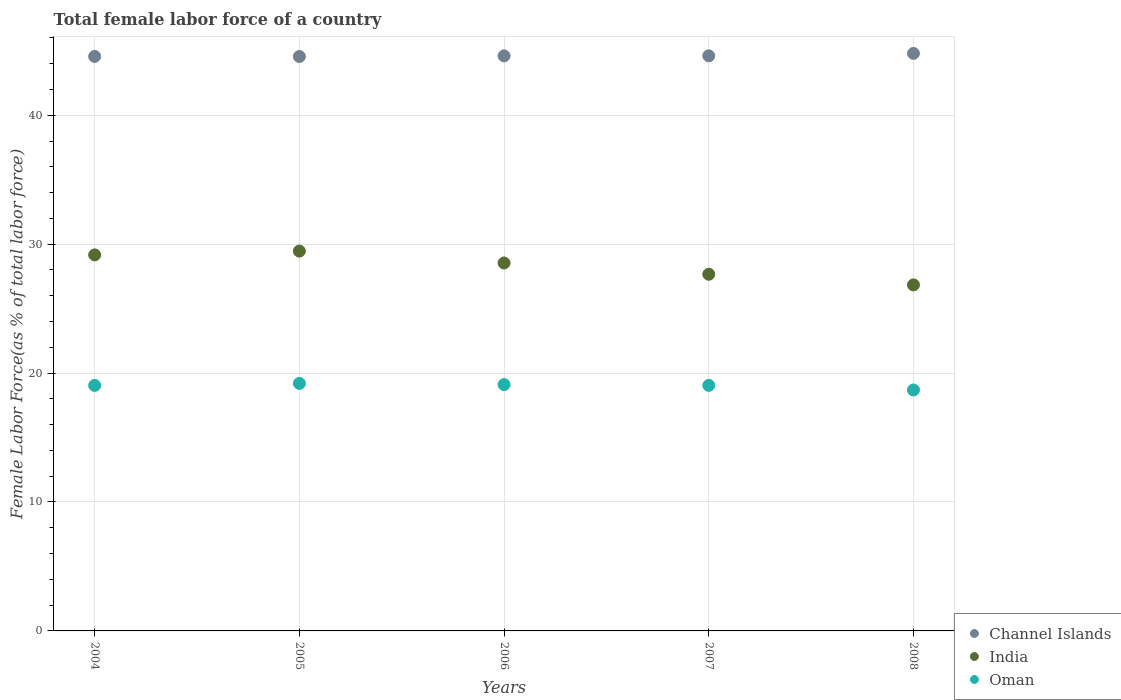How many different coloured dotlines are there?
Make the answer very short. 3. What is the percentage of female labor force in Channel Islands in 2004?
Your answer should be very brief. 44.56. Across all years, what is the maximum percentage of female labor force in Oman?
Your answer should be very brief. 19.2. Across all years, what is the minimum percentage of female labor force in India?
Provide a short and direct response. 26.84. What is the total percentage of female labor force in Channel Islands in the graph?
Offer a very short reply. 223.12. What is the difference between the percentage of female labor force in India in 2004 and that in 2006?
Make the answer very short. 0.63. What is the difference between the percentage of female labor force in India in 2006 and the percentage of female labor force in Channel Islands in 2005?
Offer a very short reply. -16.01. What is the average percentage of female labor force in India per year?
Provide a short and direct response. 28.33. In the year 2008, what is the difference between the percentage of female labor force in India and percentage of female labor force in Channel Islands?
Provide a short and direct response. -17.96. In how many years, is the percentage of female labor force in Oman greater than 10 %?
Offer a very short reply. 5. What is the ratio of the percentage of female labor force in Channel Islands in 2006 to that in 2008?
Provide a succinct answer. 1. What is the difference between the highest and the second highest percentage of female labor force in Channel Islands?
Keep it short and to the point. 0.19. What is the difference between the highest and the lowest percentage of female labor force in Oman?
Ensure brevity in your answer.  0.51. In how many years, is the percentage of female labor force in Channel Islands greater than the average percentage of female labor force in Channel Islands taken over all years?
Give a very brief answer. 1. Is the sum of the percentage of female labor force in Oman in 2004 and 2005 greater than the maximum percentage of female labor force in Channel Islands across all years?
Ensure brevity in your answer.  No. Does the percentage of female labor force in India monotonically increase over the years?
Make the answer very short. No. Is the percentage of female labor force in India strictly less than the percentage of female labor force in Channel Islands over the years?
Make the answer very short. Yes. How many dotlines are there?
Your answer should be compact. 3. How many years are there in the graph?
Make the answer very short. 5. Are the values on the major ticks of Y-axis written in scientific E-notation?
Keep it short and to the point. No. Does the graph contain any zero values?
Make the answer very short. No. Where does the legend appear in the graph?
Provide a short and direct response. Bottom right. What is the title of the graph?
Offer a terse response. Total female labor force of a country. What is the label or title of the Y-axis?
Your answer should be very brief. Female Labor Force(as % of total labor force). What is the Female Labor Force(as % of total labor force) of Channel Islands in 2004?
Your answer should be compact. 44.56. What is the Female Labor Force(as % of total labor force) in India in 2004?
Give a very brief answer. 29.17. What is the Female Labor Force(as % of total labor force) of Oman in 2004?
Keep it short and to the point. 19.04. What is the Female Labor Force(as % of total labor force) of Channel Islands in 2005?
Make the answer very short. 44.55. What is the Female Labor Force(as % of total labor force) in India in 2005?
Ensure brevity in your answer.  29.46. What is the Female Labor Force(as % of total labor force) of Oman in 2005?
Offer a terse response. 19.2. What is the Female Labor Force(as % of total labor force) in Channel Islands in 2006?
Provide a short and direct response. 44.6. What is the Female Labor Force(as % of total labor force) of India in 2006?
Ensure brevity in your answer.  28.54. What is the Female Labor Force(as % of total labor force) in Oman in 2006?
Make the answer very short. 19.11. What is the Female Labor Force(as % of total labor force) of Channel Islands in 2007?
Make the answer very short. 44.61. What is the Female Labor Force(as % of total labor force) in India in 2007?
Your response must be concise. 27.66. What is the Female Labor Force(as % of total labor force) in Oman in 2007?
Your response must be concise. 19.04. What is the Female Labor Force(as % of total labor force) in Channel Islands in 2008?
Provide a succinct answer. 44.79. What is the Female Labor Force(as % of total labor force) of India in 2008?
Your answer should be very brief. 26.84. What is the Female Labor Force(as % of total labor force) of Oman in 2008?
Keep it short and to the point. 18.69. Across all years, what is the maximum Female Labor Force(as % of total labor force) in Channel Islands?
Offer a very short reply. 44.79. Across all years, what is the maximum Female Labor Force(as % of total labor force) of India?
Offer a very short reply. 29.46. Across all years, what is the maximum Female Labor Force(as % of total labor force) in Oman?
Provide a succinct answer. 19.2. Across all years, what is the minimum Female Labor Force(as % of total labor force) of Channel Islands?
Your answer should be compact. 44.55. Across all years, what is the minimum Female Labor Force(as % of total labor force) of India?
Provide a succinct answer. 26.84. Across all years, what is the minimum Female Labor Force(as % of total labor force) in Oman?
Keep it short and to the point. 18.69. What is the total Female Labor Force(as % of total labor force) of Channel Islands in the graph?
Provide a succinct answer. 223.12. What is the total Female Labor Force(as % of total labor force) of India in the graph?
Provide a succinct answer. 141.67. What is the total Female Labor Force(as % of total labor force) in Oman in the graph?
Offer a very short reply. 95.08. What is the difference between the Female Labor Force(as % of total labor force) of Channel Islands in 2004 and that in 2005?
Make the answer very short. 0.01. What is the difference between the Female Labor Force(as % of total labor force) in India in 2004 and that in 2005?
Make the answer very short. -0.29. What is the difference between the Female Labor Force(as % of total labor force) in Oman in 2004 and that in 2005?
Your answer should be compact. -0.16. What is the difference between the Female Labor Force(as % of total labor force) in Channel Islands in 2004 and that in 2006?
Ensure brevity in your answer.  -0.04. What is the difference between the Female Labor Force(as % of total labor force) of India in 2004 and that in 2006?
Provide a succinct answer. 0.63. What is the difference between the Female Labor Force(as % of total labor force) in Oman in 2004 and that in 2006?
Provide a succinct answer. -0.07. What is the difference between the Female Labor Force(as % of total labor force) of Channel Islands in 2004 and that in 2007?
Offer a terse response. -0.05. What is the difference between the Female Labor Force(as % of total labor force) in India in 2004 and that in 2007?
Ensure brevity in your answer.  1.5. What is the difference between the Female Labor Force(as % of total labor force) in Oman in 2004 and that in 2007?
Give a very brief answer. -0. What is the difference between the Female Labor Force(as % of total labor force) of Channel Islands in 2004 and that in 2008?
Keep it short and to the point. -0.23. What is the difference between the Female Labor Force(as % of total labor force) of India in 2004 and that in 2008?
Offer a very short reply. 2.33. What is the difference between the Female Labor Force(as % of total labor force) of Oman in 2004 and that in 2008?
Provide a short and direct response. 0.35. What is the difference between the Female Labor Force(as % of total labor force) in Channel Islands in 2005 and that in 2006?
Offer a terse response. -0.05. What is the difference between the Female Labor Force(as % of total labor force) in India in 2005 and that in 2006?
Give a very brief answer. 0.92. What is the difference between the Female Labor Force(as % of total labor force) of Oman in 2005 and that in 2006?
Give a very brief answer. 0.09. What is the difference between the Female Labor Force(as % of total labor force) of Channel Islands in 2005 and that in 2007?
Give a very brief answer. -0.06. What is the difference between the Female Labor Force(as % of total labor force) in India in 2005 and that in 2007?
Your response must be concise. 1.79. What is the difference between the Female Labor Force(as % of total labor force) of Oman in 2005 and that in 2007?
Keep it short and to the point. 0.16. What is the difference between the Female Labor Force(as % of total labor force) of Channel Islands in 2005 and that in 2008?
Your answer should be very brief. -0.24. What is the difference between the Female Labor Force(as % of total labor force) of India in 2005 and that in 2008?
Offer a terse response. 2.62. What is the difference between the Female Labor Force(as % of total labor force) in Oman in 2005 and that in 2008?
Your response must be concise. 0.51. What is the difference between the Female Labor Force(as % of total labor force) in Channel Islands in 2006 and that in 2007?
Give a very brief answer. -0.01. What is the difference between the Female Labor Force(as % of total labor force) in India in 2006 and that in 2007?
Provide a succinct answer. 0.87. What is the difference between the Female Labor Force(as % of total labor force) in Oman in 2006 and that in 2007?
Make the answer very short. 0.06. What is the difference between the Female Labor Force(as % of total labor force) in Channel Islands in 2006 and that in 2008?
Your response must be concise. -0.19. What is the difference between the Female Labor Force(as % of total labor force) in India in 2006 and that in 2008?
Provide a succinct answer. 1.7. What is the difference between the Female Labor Force(as % of total labor force) of Oman in 2006 and that in 2008?
Your answer should be very brief. 0.42. What is the difference between the Female Labor Force(as % of total labor force) in Channel Islands in 2007 and that in 2008?
Provide a short and direct response. -0.19. What is the difference between the Female Labor Force(as % of total labor force) in India in 2007 and that in 2008?
Give a very brief answer. 0.83. What is the difference between the Female Labor Force(as % of total labor force) of Oman in 2007 and that in 2008?
Keep it short and to the point. 0.36. What is the difference between the Female Labor Force(as % of total labor force) of Channel Islands in 2004 and the Female Labor Force(as % of total labor force) of India in 2005?
Ensure brevity in your answer.  15.1. What is the difference between the Female Labor Force(as % of total labor force) of Channel Islands in 2004 and the Female Labor Force(as % of total labor force) of Oman in 2005?
Keep it short and to the point. 25.36. What is the difference between the Female Labor Force(as % of total labor force) in India in 2004 and the Female Labor Force(as % of total labor force) in Oman in 2005?
Provide a short and direct response. 9.97. What is the difference between the Female Labor Force(as % of total labor force) in Channel Islands in 2004 and the Female Labor Force(as % of total labor force) in India in 2006?
Offer a very short reply. 16.02. What is the difference between the Female Labor Force(as % of total labor force) in Channel Islands in 2004 and the Female Labor Force(as % of total labor force) in Oman in 2006?
Provide a succinct answer. 25.45. What is the difference between the Female Labor Force(as % of total labor force) in India in 2004 and the Female Labor Force(as % of total labor force) in Oman in 2006?
Your answer should be compact. 10.06. What is the difference between the Female Labor Force(as % of total labor force) of Channel Islands in 2004 and the Female Labor Force(as % of total labor force) of India in 2007?
Keep it short and to the point. 16.9. What is the difference between the Female Labor Force(as % of total labor force) in Channel Islands in 2004 and the Female Labor Force(as % of total labor force) in Oman in 2007?
Keep it short and to the point. 25.52. What is the difference between the Female Labor Force(as % of total labor force) of India in 2004 and the Female Labor Force(as % of total labor force) of Oman in 2007?
Your response must be concise. 10.12. What is the difference between the Female Labor Force(as % of total labor force) of Channel Islands in 2004 and the Female Labor Force(as % of total labor force) of India in 2008?
Your answer should be compact. 17.72. What is the difference between the Female Labor Force(as % of total labor force) of Channel Islands in 2004 and the Female Labor Force(as % of total labor force) of Oman in 2008?
Provide a short and direct response. 25.87. What is the difference between the Female Labor Force(as % of total labor force) in India in 2004 and the Female Labor Force(as % of total labor force) in Oman in 2008?
Your answer should be very brief. 10.48. What is the difference between the Female Labor Force(as % of total labor force) in Channel Islands in 2005 and the Female Labor Force(as % of total labor force) in India in 2006?
Offer a terse response. 16.01. What is the difference between the Female Labor Force(as % of total labor force) of Channel Islands in 2005 and the Female Labor Force(as % of total labor force) of Oman in 2006?
Make the answer very short. 25.45. What is the difference between the Female Labor Force(as % of total labor force) of India in 2005 and the Female Labor Force(as % of total labor force) of Oman in 2006?
Your answer should be compact. 10.35. What is the difference between the Female Labor Force(as % of total labor force) in Channel Islands in 2005 and the Female Labor Force(as % of total labor force) in India in 2007?
Provide a short and direct response. 16.89. What is the difference between the Female Labor Force(as % of total labor force) in Channel Islands in 2005 and the Female Labor Force(as % of total labor force) in Oman in 2007?
Give a very brief answer. 25.51. What is the difference between the Female Labor Force(as % of total labor force) in India in 2005 and the Female Labor Force(as % of total labor force) in Oman in 2007?
Your answer should be very brief. 10.42. What is the difference between the Female Labor Force(as % of total labor force) in Channel Islands in 2005 and the Female Labor Force(as % of total labor force) in India in 2008?
Your answer should be compact. 17.71. What is the difference between the Female Labor Force(as % of total labor force) of Channel Islands in 2005 and the Female Labor Force(as % of total labor force) of Oman in 2008?
Keep it short and to the point. 25.86. What is the difference between the Female Labor Force(as % of total labor force) in India in 2005 and the Female Labor Force(as % of total labor force) in Oman in 2008?
Your response must be concise. 10.77. What is the difference between the Female Labor Force(as % of total labor force) of Channel Islands in 2006 and the Female Labor Force(as % of total labor force) of India in 2007?
Ensure brevity in your answer.  16.94. What is the difference between the Female Labor Force(as % of total labor force) of Channel Islands in 2006 and the Female Labor Force(as % of total labor force) of Oman in 2007?
Provide a succinct answer. 25.56. What is the difference between the Female Labor Force(as % of total labor force) in India in 2006 and the Female Labor Force(as % of total labor force) in Oman in 2007?
Your response must be concise. 9.5. What is the difference between the Female Labor Force(as % of total labor force) of Channel Islands in 2006 and the Female Labor Force(as % of total labor force) of India in 2008?
Offer a very short reply. 17.76. What is the difference between the Female Labor Force(as % of total labor force) in Channel Islands in 2006 and the Female Labor Force(as % of total labor force) in Oman in 2008?
Make the answer very short. 25.92. What is the difference between the Female Labor Force(as % of total labor force) in India in 2006 and the Female Labor Force(as % of total labor force) in Oman in 2008?
Your answer should be compact. 9.85. What is the difference between the Female Labor Force(as % of total labor force) in Channel Islands in 2007 and the Female Labor Force(as % of total labor force) in India in 2008?
Make the answer very short. 17.77. What is the difference between the Female Labor Force(as % of total labor force) of Channel Islands in 2007 and the Female Labor Force(as % of total labor force) of Oman in 2008?
Ensure brevity in your answer.  25.92. What is the difference between the Female Labor Force(as % of total labor force) of India in 2007 and the Female Labor Force(as % of total labor force) of Oman in 2008?
Your answer should be compact. 8.98. What is the average Female Labor Force(as % of total labor force) in Channel Islands per year?
Keep it short and to the point. 44.62. What is the average Female Labor Force(as % of total labor force) in India per year?
Offer a terse response. 28.33. What is the average Female Labor Force(as % of total labor force) of Oman per year?
Your answer should be very brief. 19.02. In the year 2004, what is the difference between the Female Labor Force(as % of total labor force) of Channel Islands and Female Labor Force(as % of total labor force) of India?
Your answer should be very brief. 15.39. In the year 2004, what is the difference between the Female Labor Force(as % of total labor force) in Channel Islands and Female Labor Force(as % of total labor force) in Oman?
Offer a terse response. 25.52. In the year 2004, what is the difference between the Female Labor Force(as % of total labor force) in India and Female Labor Force(as % of total labor force) in Oman?
Keep it short and to the point. 10.12. In the year 2005, what is the difference between the Female Labor Force(as % of total labor force) of Channel Islands and Female Labor Force(as % of total labor force) of India?
Your response must be concise. 15.09. In the year 2005, what is the difference between the Female Labor Force(as % of total labor force) in Channel Islands and Female Labor Force(as % of total labor force) in Oman?
Your response must be concise. 25.35. In the year 2005, what is the difference between the Female Labor Force(as % of total labor force) of India and Female Labor Force(as % of total labor force) of Oman?
Your response must be concise. 10.26. In the year 2006, what is the difference between the Female Labor Force(as % of total labor force) of Channel Islands and Female Labor Force(as % of total labor force) of India?
Your answer should be compact. 16.06. In the year 2006, what is the difference between the Female Labor Force(as % of total labor force) in Channel Islands and Female Labor Force(as % of total labor force) in Oman?
Your answer should be compact. 25.5. In the year 2006, what is the difference between the Female Labor Force(as % of total labor force) of India and Female Labor Force(as % of total labor force) of Oman?
Offer a terse response. 9.43. In the year 2007, what is the difference between the Female Labor Force(as % of total labor force) in Channel Islands and Female Labor Force(as % of total labor force) in India?
Your answer should be compact. 16.94. In the year 2007, what is the difference between the Female Labor Force(as % of total labor force) of Channel Islands and Female Labor Force(as % of total labor force) of Oman?
Ensure brevity in your answer.  25.57. In the year 2007, what is the difference between the Female Labor Force(as % of total labor force) of India and Female Labor Force(as % of total labor force) of Oman?
Provide a succinct answer. 8.62. In the year 2008, what is the difference between the Female Labor Force(as % of total labor force) in Channel Islands and Female Labor Force(as % of total labor force) in India?
Your answer should be very brief. 17.96. In the year 2008, what is the difference between the Female Labor Force(as % of total labor force) of Channel Islands and Female Labor Force(as % of total labor force) of Oman?
Offer a terse response. 26.11. In the year 2008, what is the difference between the Female Labor Force(as % of total labor force) in India and Female Labor Force(as % of total labor force) in Oman?
Ensure brevity in your answer.  8.15. What is the ratio of the Female Labor Force(as % of total labor force) in Channel Islands in 2004 to that in 2005?
Provide a succinct answer. 1. What is the ratio of the Female Labor Force(as % of total labor force) of India in 2004 to that in 2005?
Your answer should be compact. 0.99. What is the ratio of the Female Labor Force(as % of total labor force) in Oman in 2004 to that in 2006?
Provide a short and direct response. 1. What is the ratio of the Female Labor Force(as % of total labor force) in Channel Islands in 2004 to that in 2007?
Ensure brevity in your answer.  1. What is the ratio of the Female Labor Force(as % of total labor force) in India in 2004 to that in 2007?
Provide a short and direct response. 1.05. What is the ratio of the Female Labor Force(as % of total labor force) in Channel Islands in 2004 to that in 2008?
Ensure brevity in your answer.  0.99. What is the ratio of the Female Labor Force(as % of total labor force) of India in 2004 to that in 2008?
Keep it short and to the point. 1.09. What is the ratio of the Female Labor Force(as % of total labor force) of Oman in 2004 to that in 2008?
Provide a succinct answer. 1.02. What is the ratio of the Female Labor Force(as % of total labor force) in India in 2005 to that in 2006?
Make the answer very short. 1.03. What is the ratio of the Female Labor Force(as % of total labor force) in India in 2005 to that in 2007?
Your response must be concise. 1.06. What is the ratio of the Female Labor Force(as % of total labor force) of Oman in 2005 to that in 2007?
Give a very brief answer. 1.01. What is the ratio of the Female Labor Force(as % of total labor force) of Channel Islands in 2005 to that in 2008?
Your response must be concise. 0.99. What is the ratio of the Female Labor Force(as % of total labor force) in India in 2005 to that in 2008?
Ensure brevity in your answer.  1.1. What is the ratio of the Female Labor Force(as % of total labor force) of Oman in 2005 to that in 2008?
Give a very brief answer. 1.03. What is the ratio of the Female Labor Force(as % of total labor force) in Channel Islands in 2006 to that in 2007?
Give a very brief answer. 1. What is the ratio of the Female Labor Force(as % of total labor force) of India in 2006 to that in 2007?
Keep it short and to the point. 1.03. What is the ratio of the Female Labor Force(as % of total labor force) of Channel Islands in 2006 to that in 2008?
Ensure brevity in your answer.  1. What is the ratio of the Female Labor Force(as % of total labor force) in India in 2006 to that in 2008?
Your response must be concise. 1.06. What is the ratio of the Female Labor Force(as % of total labor force) in Oman in 2006 to that in 2008?
Your answer should be compact. 1.02. What is the ratio of the Female Labor Force(as % of total labor force) of India in 2007 to that in 2008?
Give a very brief answer. 1.03. What is the ratio of the Female Labor Force(as % of total labor force) of Oman in 2007 to that in 2008?
Make the answer very short. 1.02. What is the difference between the highest and the second highest Female Labor Force(as % of total labor force) in Channel Islands?
Ensure brevity in your answer.  0.19. What is the difference between the highest and the second highest Female Labor Force(as % of total labor force) of India?
Ensure brevity in your answer.  0.29. What is the difference between the highest and the second highest Female Labor Force(as % of total labor force) of Oman?
Your answer should be very brief. 0.09. What is the difference between the highest and the lowest Female Labor Force(as % of total labor force) in Channel Islands?
Keep it short and to the point. 0.24. What is the difference between the highest and the lowest Female Labor Force(as % of total labor force) of India?
Provide a short and direct response. 2.62. What is the difference between the highest and the lowest Female Labor Force(as % of total labor force) of Oman?
Your answer should be very brief. 0.51. 